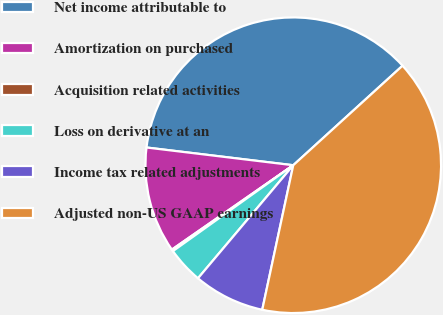Convert chart. <chart><loc_0><loc_0><loc_500><loc_500><pie_chart><fcel>Net income attributable to<fcel>Amortization on purchased<fcel>Acquisition related activities<fcel>Loss on derivative at an<fcel>Income tax related adjustments<fcel>Adjusted non-US GAAP earnings<nl><fcel>36.33%<fcel>11.58%<fcel>0.2%<fcel>3.99%<fcel>7.78%<fcel>40.12%<nl></chart> 